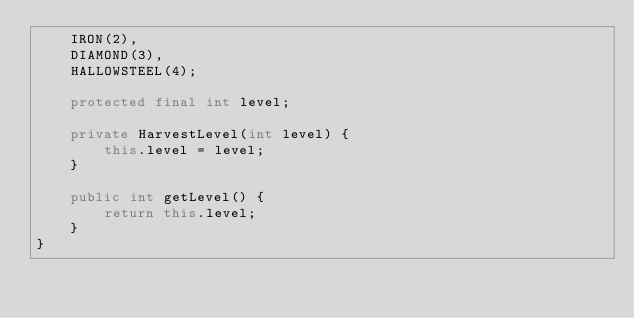<code> <loc_0><loc_0><loc_500><loc_500><_Java_>    IRON(2),
    DIAMOND(3),
    HALLOWSTEEL(4);
    
    protected final int level;
    
    private HarvestLevel(int level) {
        this.level = level;
    }
    
    public int getLevel() {
        return this.level;
    }
}
</code> 